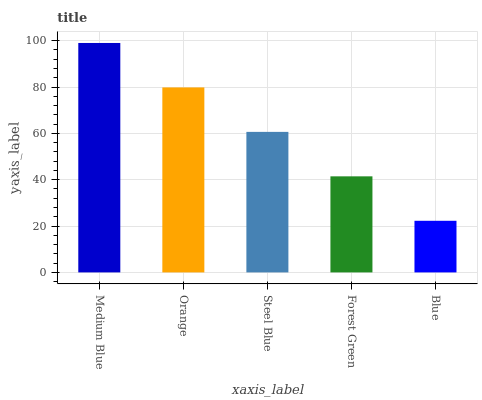Is Blue the minimum?
Answer yes or no. Yes. Is Medium Blue the maximum?
Answer yes or no. Yes. Is Orange the minimum?
Answer yes or no. No. Is Orange the maximum?
Answer yes or no. No. Is Medium Blue greater than Orange?
Answer yes or no. Yes. Is Orange less than Medium Blue?
Answer yes or no. Yes. Is Orange greater than Medium Blue?
Answer yes or no. No. Is Medium Blue less than Orange?
Answer yes or no. No. Is Steel Blue the high median?
Answer yes or no. Yes. Is Steel Blue the low median?
Answer yes or no. Yes. Is Blue the high median?
Answer yes or no. No. Is Forest Green the low median?
Answer yes or no. No. 